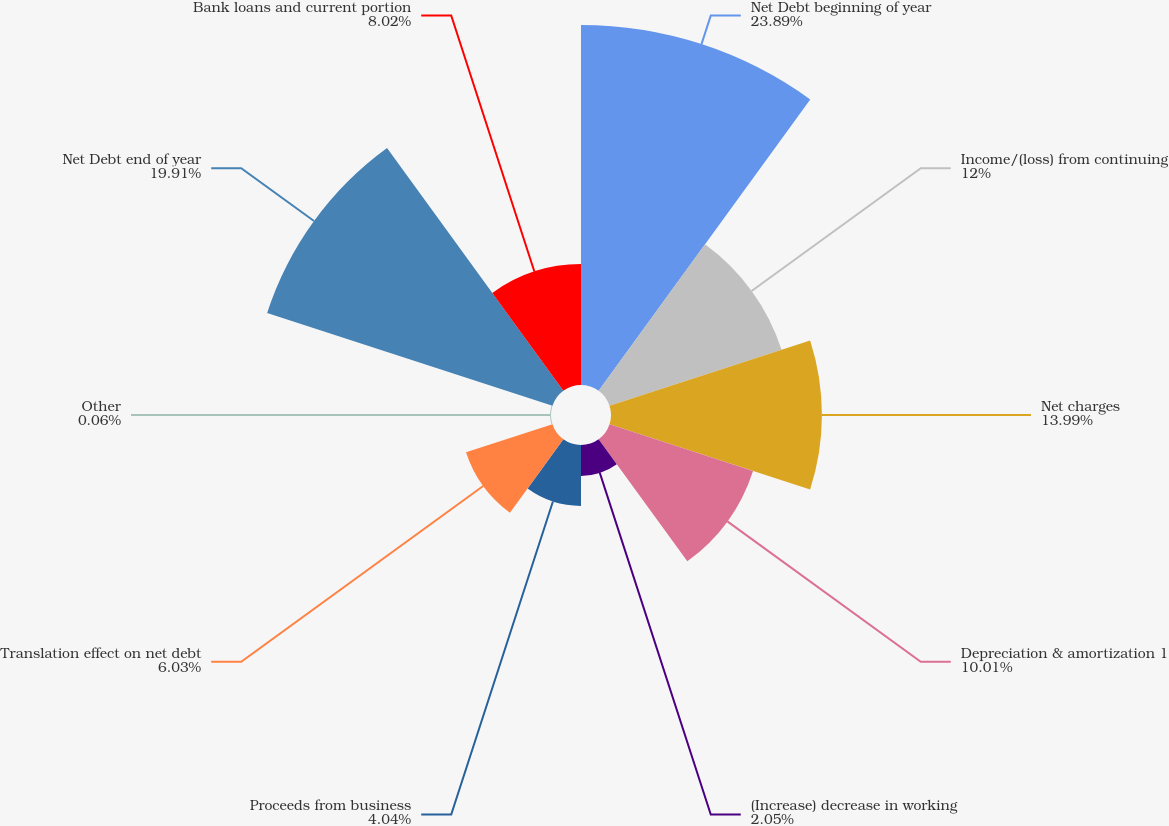Convert chart. <chart><loc_0><loc_0><loc_500><loc_500><pie_chart><fcel>Net Debt beginning of year<fcel>Income/(loss) from continuing<fcel>Net charges<fcel>Depreciation & amortization 1<fcel>(Increase) decrease in working<fcel>Proceeds from business<fcel>Translation effect on net debt<fcel>Other<fcel>Net Debt end of year<fcel>Bank loans and current portion<nl><fcel>23.88%<fcel>12.0%<fcel>13.99%<fcel>10.01%<fcel>2.05%<fcel>4.04%<fcel>6.03%<fcel>0.06%<fcel>19.9%<fcel>8.02%<nl></chart> 